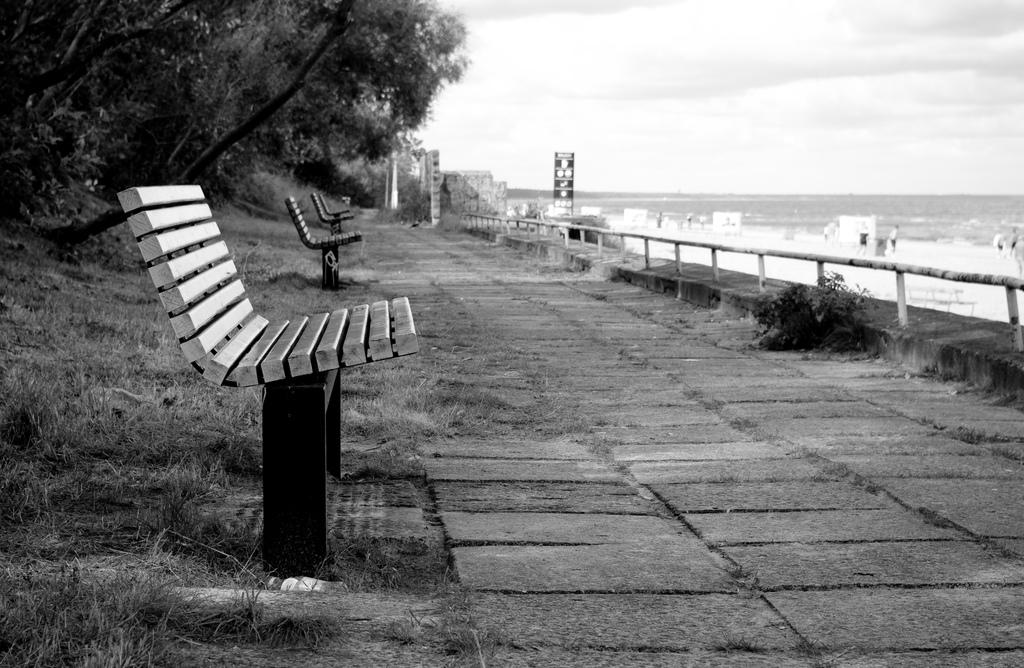What type of seating is available in the image? There are benches in the image. What type of vegetation can be seen in the image? There is grass, trees, and plants in the image. What is the purpose of the fence in the image? The purpose of the fence in the image is not specified, but it could be for enclosing an area or providing a boundary. What is the background of the image like? The background of the image is blurry, with a hoarding, people, and the sky visible. What can be seen in the sky in the image? The sky is visible in the background of the image, with clouds present. Can you hear the bell ringing in the image? There is no bell present in the image, so it cannot be heard. Is there a water fountain in the image? There is no water fountain mentioned in the provided facts, so it cannot be confirmed. 